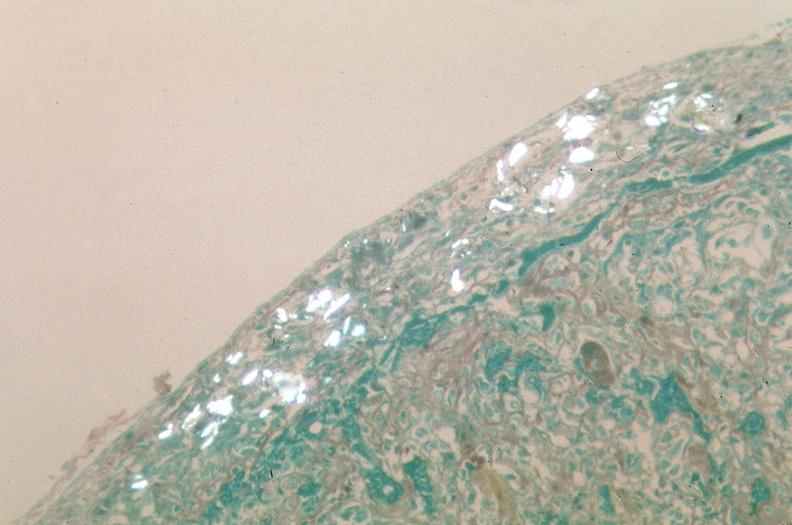what was used to sclerose emphysematous lung, alpha-1 antitrypsin deficiency?
Answer the question using a single word or phrase. Talc 